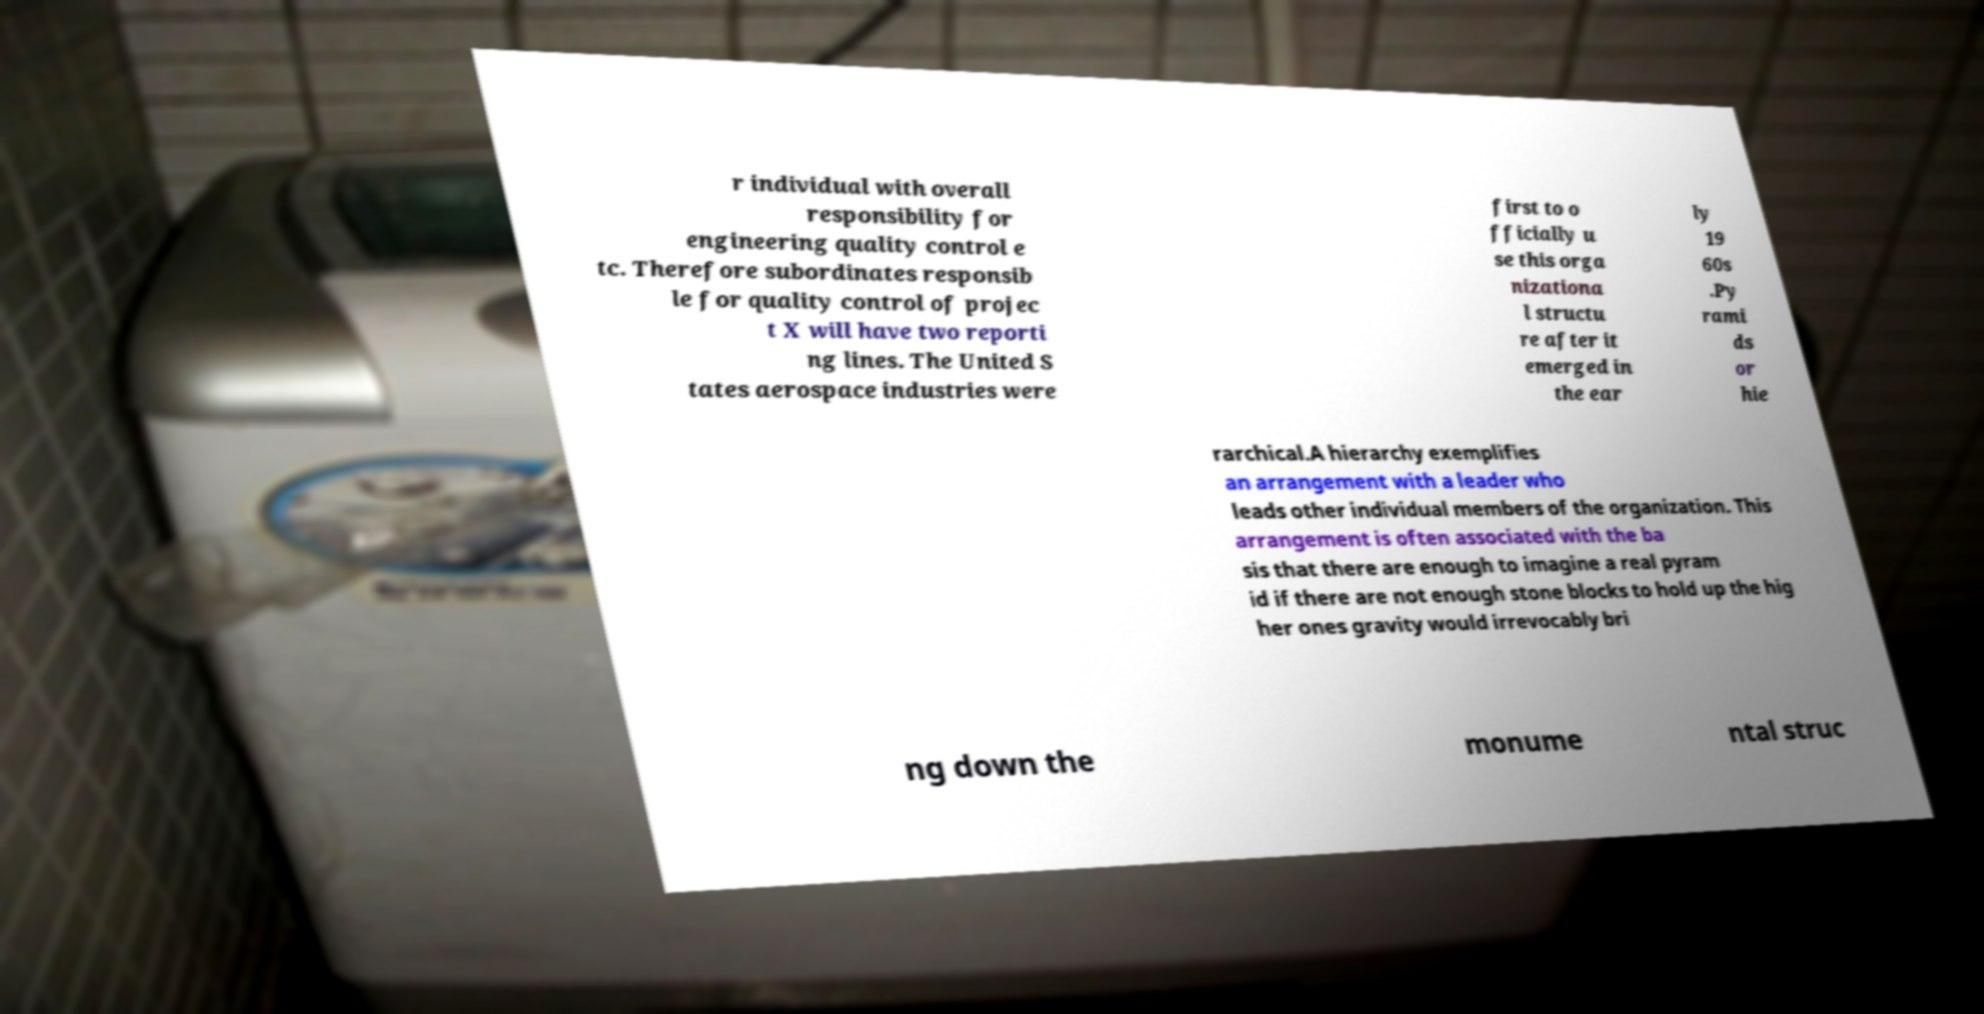I need the written content from this picture converted into text. Can you do that? r individual with overall responsibility for engineering quality control e tc. Therefore subordinates responsib le for quality control of projec t X will have two reporti ng lines. The United S tates aerospace industries were first to o fficially u se this orga nizationa l structu re after it emerged in the ear ly 19 60s .Py rami ds or hie rarchical.A hierarchy exemplifies an arrangement with a leader who leads other individual members of the organization. This arrangement is often associated with the ba sis that there are enough to imagine a real pyram id if there are not enough stone blocks to hold up the hig her ones gravity would irrevocably bri ng down the monume ntal struc 